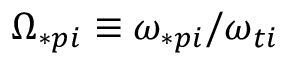<formula> <loc_0><loc_0><loc_500><loc_500>\Omega _ { \ast p i } \equiv \omega _ { \ast p i } / \omega _ { t i }</formula> 